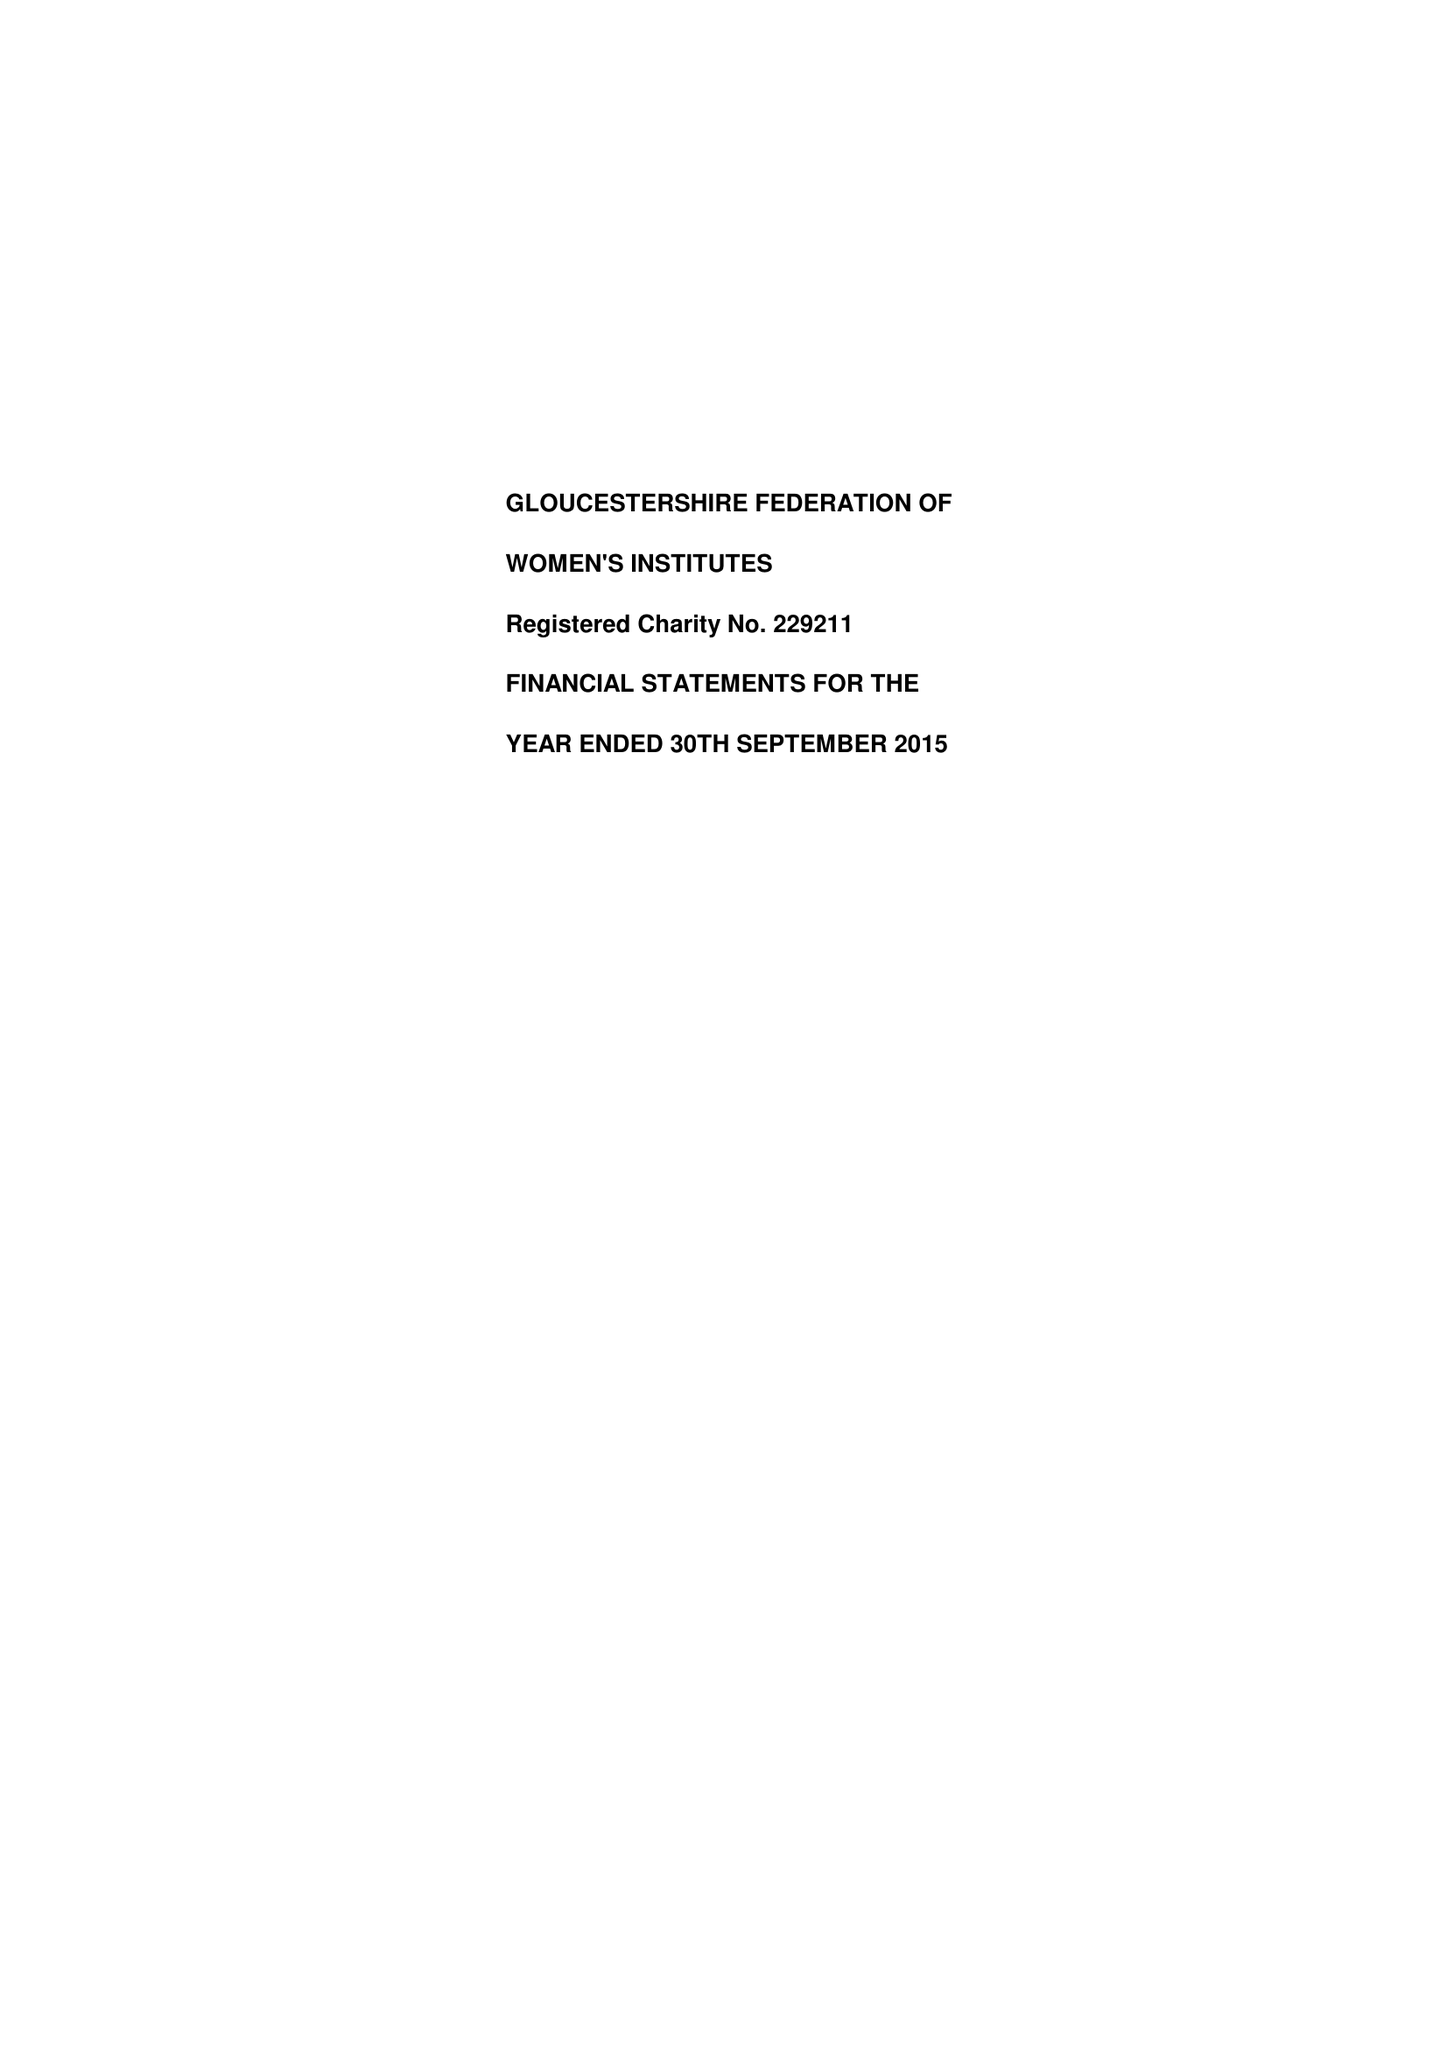What is the value for the address__post_town?
Answer the question using a single word or phrase. GLOUCESTER 